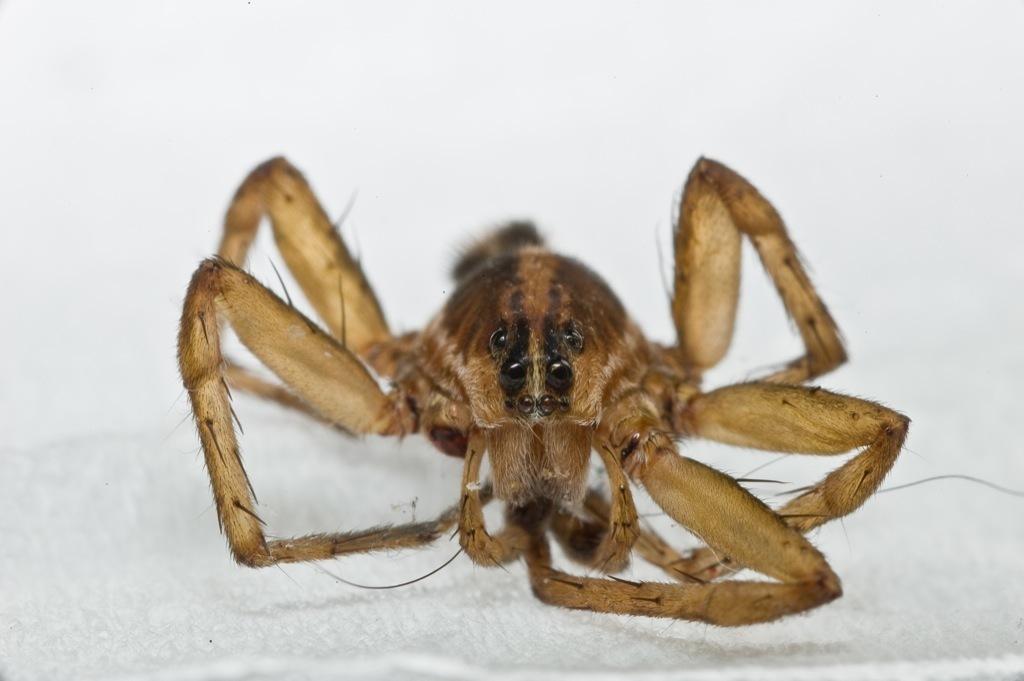Please provide a concise description of this image. In this image, we can see an insect on the white surface. 